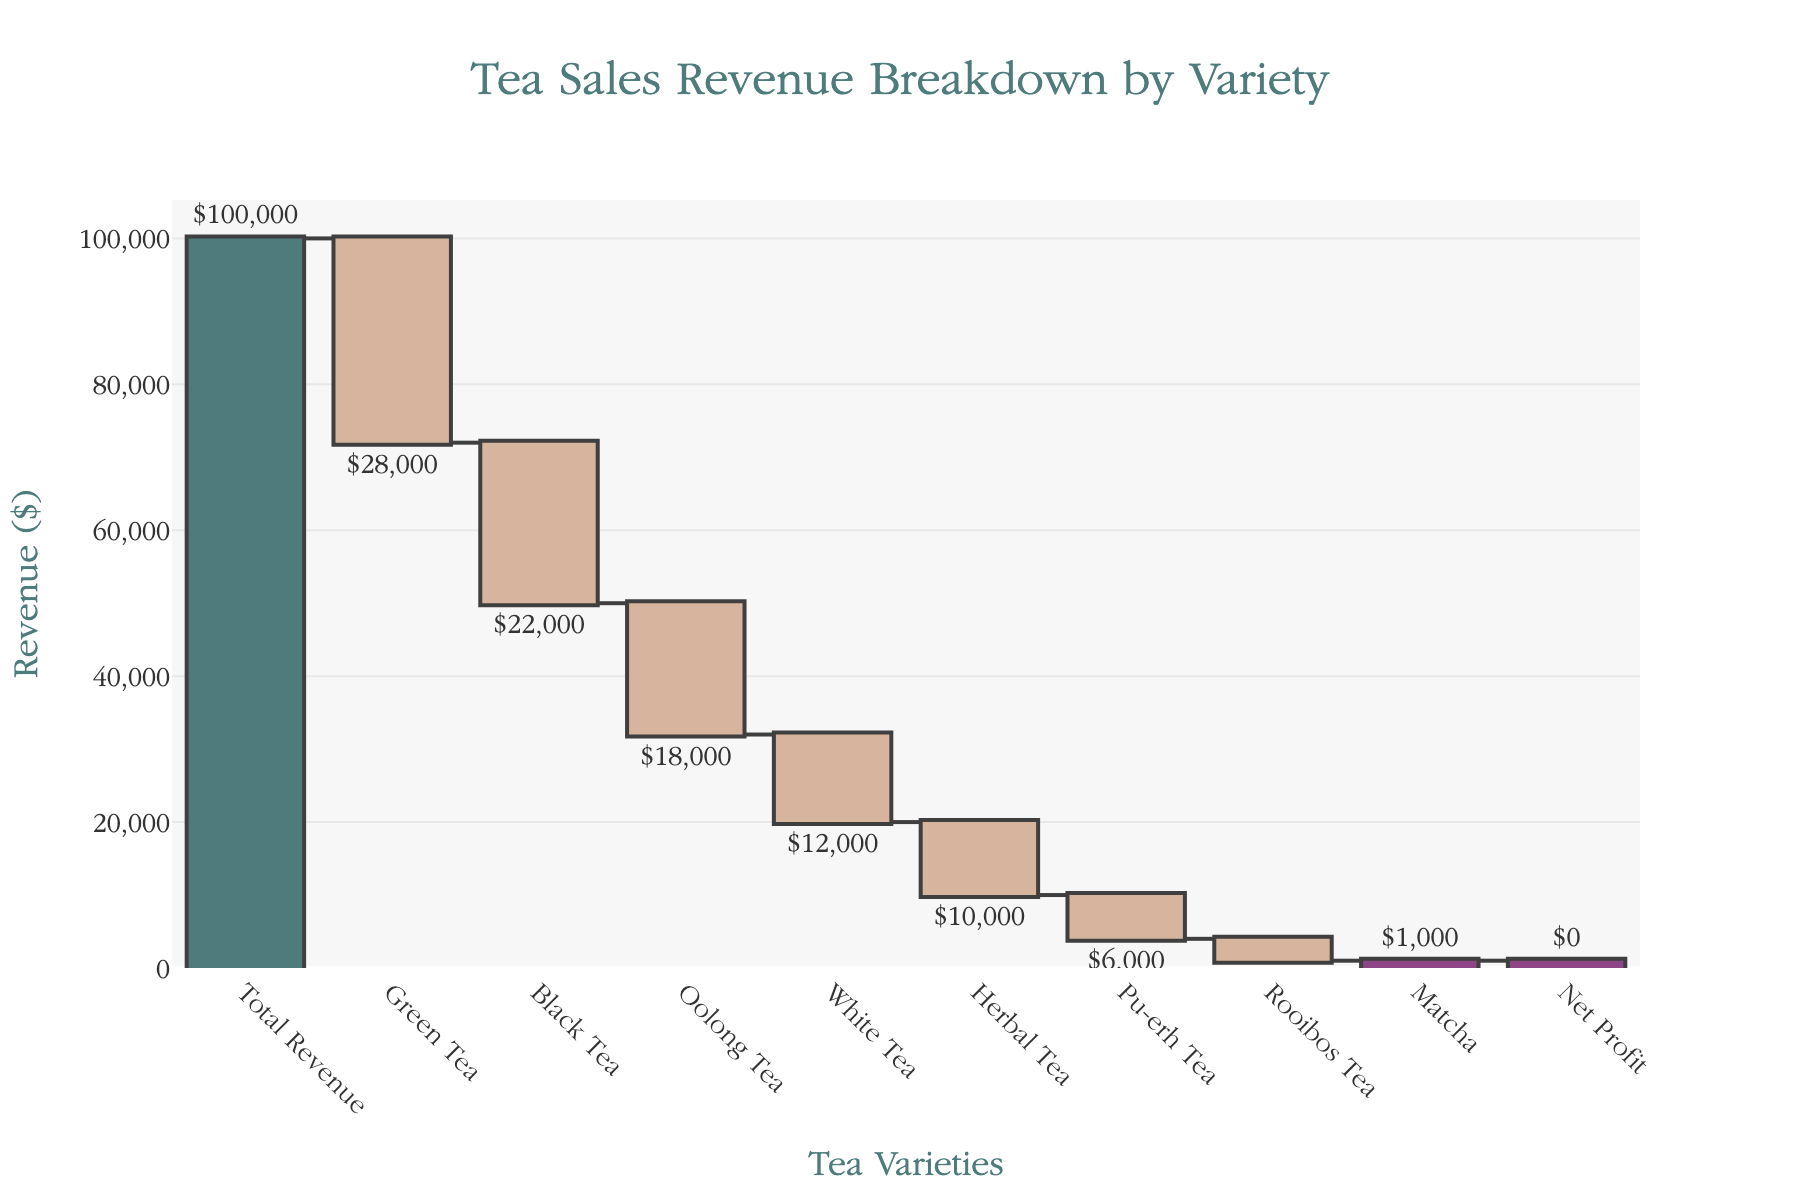What is the title of the waterfall chart? The title is displayed at the top center of the chart in a larger font size.
Answer: Tea Sales Revenue Breakdown by Variety How many tea varieties are listed in the waterfall chart? Each tea variety is represented by a bar in the chart. Count the number of bars excluding "Total Revenue" and "Net Profit".
Answer: 8 Which tea variety contributed the least to the revenue? The bar with the smallest negative value represents the least contribution. Both the label and bar height indicate the contribution amount.
Answer: Matcha What is the total revenue before deducting tea varieties? "Total Revenue" is shown as the first bar at the specified amount.
Answer: $100,000 What is the net profit at the end? The last bar labeled "Net Profit" shows the remaining amount after deducting all tea varieties' revenues from the total revenue.
Answer: $0 Which tea variety had the highest negative impact on revenue? Identify the bar with the largest negative value, indicating the highest negative contribution.
Answer: Green Tea What is the combined revenue of Green Tea, Oolong Tea, and Rooibos Tea? Add the negative values of Green Tea, Oolong Tea, and Rooibos Tea. Green Tea: -28000, Oolong Tea: -18000, Rooibos Tea: -3000. Combined: -28000 + -18000 + -3000 = -49000.
Answer: -$49,000 How does the revenue loss from Black Tea compare to Herbal Tea? Compare the negative values of Black Tea and Herbal Tea. Black Tea: -22000, Herbal Tea: -10000.
Answer: Black Tea had a higher loss Which tea varieties have a revenue impact greater than $10,000? Identify bars with a contribution value greater than -10000, indicating significant impact.
Answer: Green Tea, Black Tea, Oolong Tea, White Tea What is the total revenue loss from all tea varieties combined? Sum all the negative values of the tea varieties. Green Tea: -28000, Black Tea: -22000, Oolong Tea: -18000, White Tea: -12000, Herbal Tea: -10000, Pu-erh Tea: -6000, Rooibos Tea: -3000, Matcha: -1000. Total: -28000 + -22000 + -18000 + -12000 + -10000 + -6000 + -3000 + -1000 = -100000.
Answer: -$100,000 